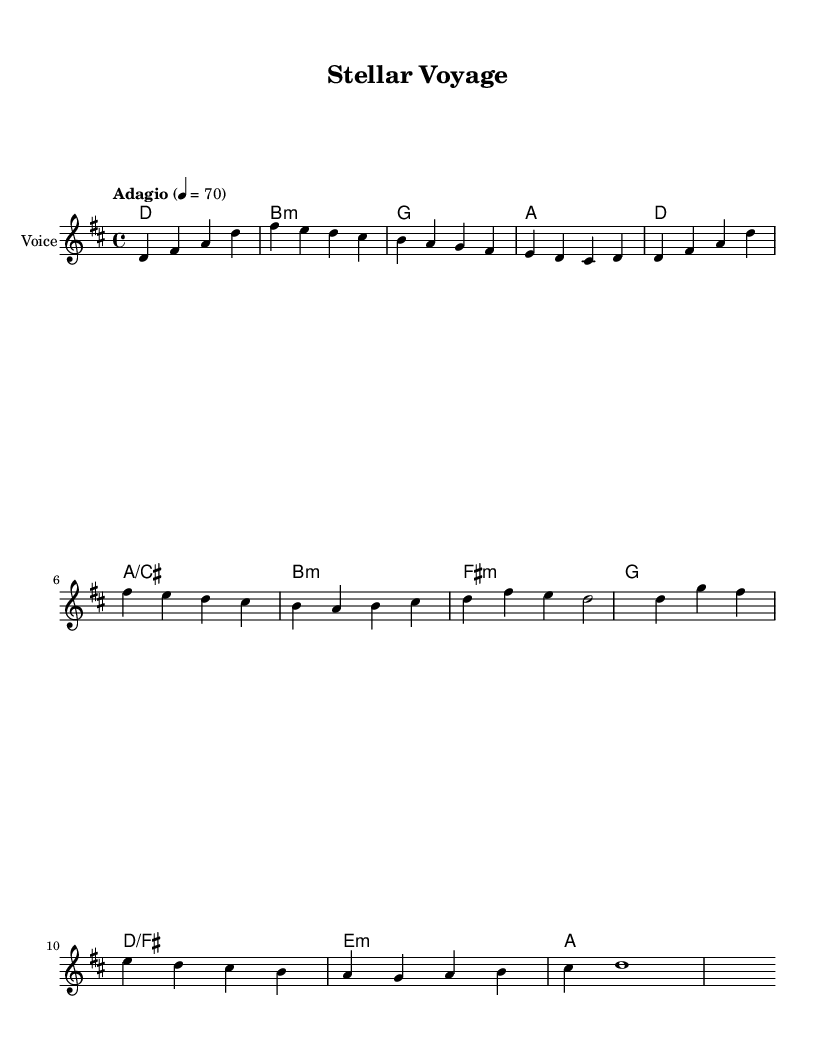What is the key signature of this music? The key signature is indicated by the sharps or flats at the beginning of the staff. In this case, there are two sharps (F# and C#), which corresponds to D major.
Answer: D major What is the time signature of this music? The time signature is shown at the beginning of the score after the key signature. Here, it shows a numerator of 4 and a denominator of 4, indicating a standard four beats per measure.
Answer: 4/4 What is the tempo marking of this piece? The tempo marking is typically written relative to the beats per minute (BPM). The marking "Adagio" suggests a slow tempo, and the number 70 indicates the beats per minute.
Answer: Adagio, 70 What is the first note of the melody? The first note of the melody is found at the beginning of the staff and corresponds to the pitch notated there. The first note shown is D, as indicated in the score.
Answer: D How many measures are in the Chorus section? The Chorus is discerned from the structure of the music, particularly in the lyrics, which begin after the Verse and are marked separately. Counting the measures from the indication, there are four measures in the Chorus section.
Answer: 4 What instruments are indicated for this opera? The instruments used in an opera can often be seen in the header or at the beginning of the score. In this case, it specifies that the instrument is "Voice" with a MIDI instrument of "voice oohs."
Answer: Voice What theme does this opera represent? The theme of the opera can be deduced from the title and the lyrics provided, which discuss cosmic exploration and the mysteries of the universe. This indicates a space exploration theme.
Answer: Space exploration 